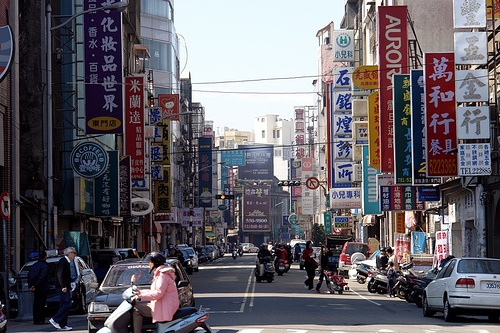Describe the objects in this image and their specific colors. I can see car in black, darkgray, and gray tones, car in black, gray, and darkgray tones, people in black, gray, and white tones, car in black, gray, navy, and darkgray tones, and people in black, brown, gray, and white tones in this image. 